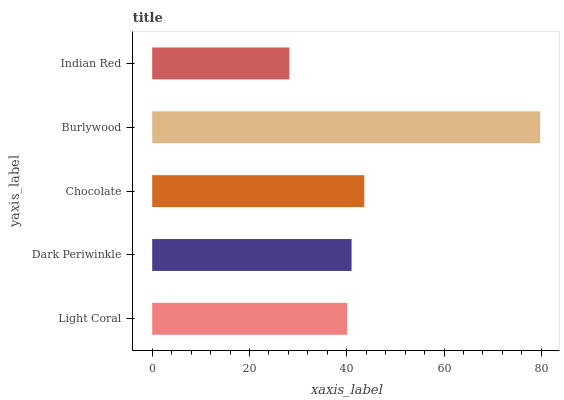Is Indian Red the minimum?
Answer yes or no. Yes. Is Burlywood the maximum?
Answer yes or no. Yes. Is Dark Periwinkle the minimum?
Answer yes or no. No. Is Dark Periwinkle the maximum?
Answer yes or no. No. Is Dark Periwinkle greater than Light Coral?
Answer yes or no. Yes. Is Light Coral less than Dark Periwinkle?
Answer yes or no. Yes. Is Light Coral greater than Dark Periwinkle?
Answer yes or no. No. Is Dark Periwinkle less than Light Coral?
Answer yes or no. No. Is Dark Periwinkle the high median?
Answer yes or no. Yes. Is Dark Periwinkle the low median?
Answer yes or no. Yes. Is Burlywood the high median?
Answer yes or no. No. Is Indian Red the low median?
Answer yes or no. No. 